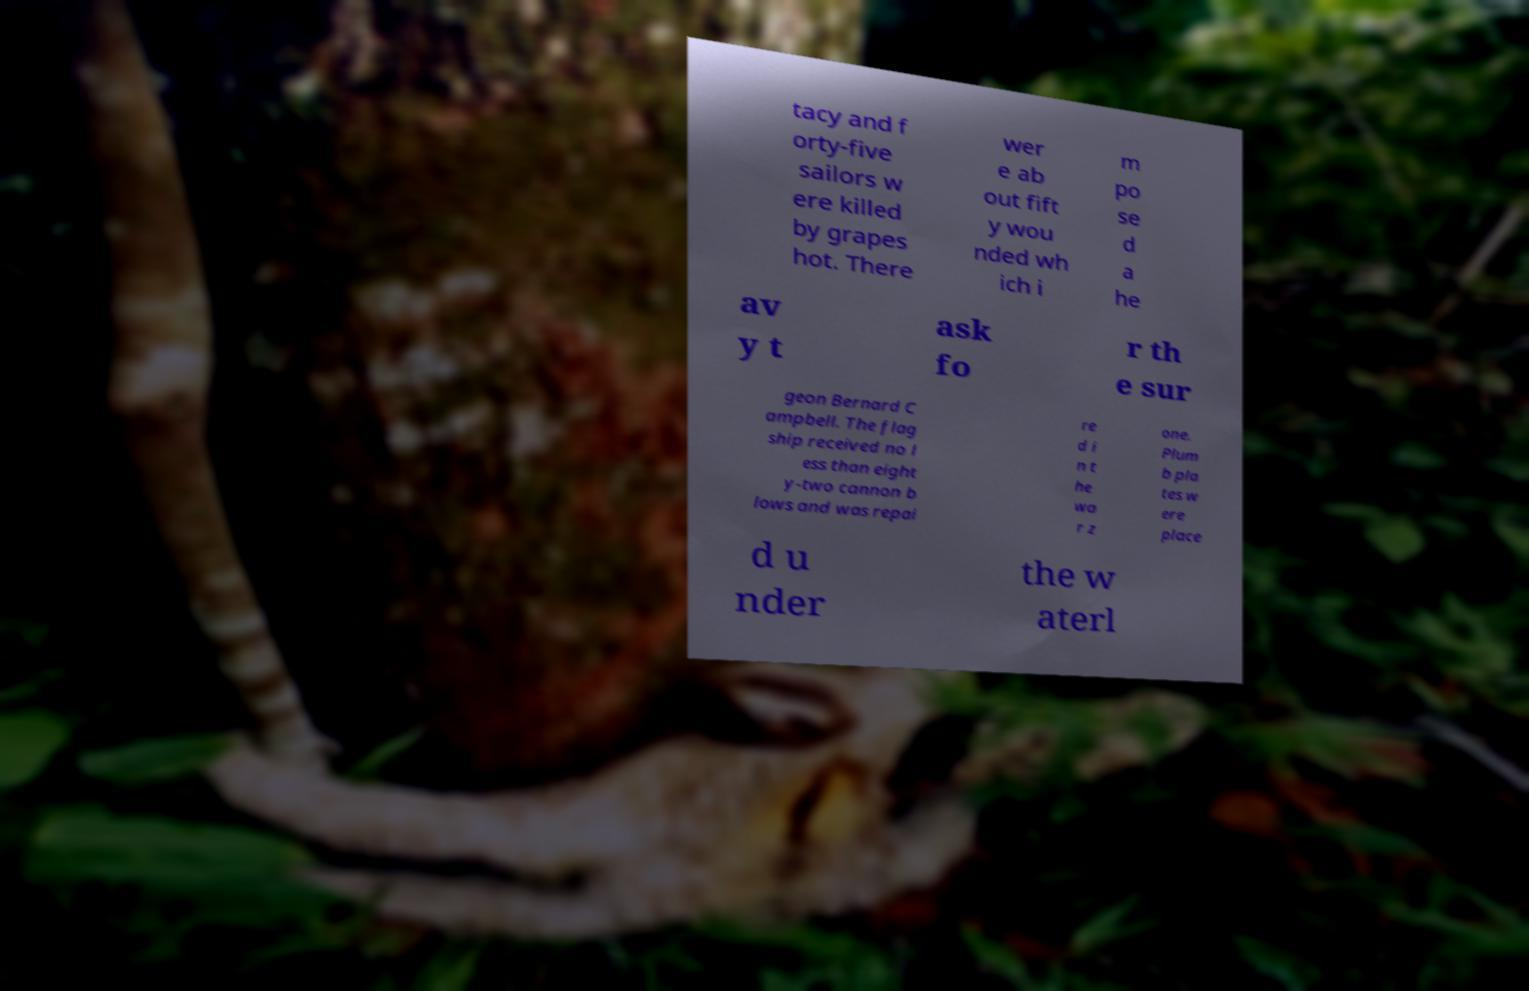Could you extract and type out the text from this image? tacy and f orty-five sailors w ere killed by grapes hot. There wer e ab out fift y wou nded wh ich i m po se d a he av y t ask fo r th e sur geon Bernard C ampbell. The flag ship received no l ess than eight y-two cannon b lows and was repai re d i n t he wa r z one. Plum b pla tes w ere place d u nder the w aterl 